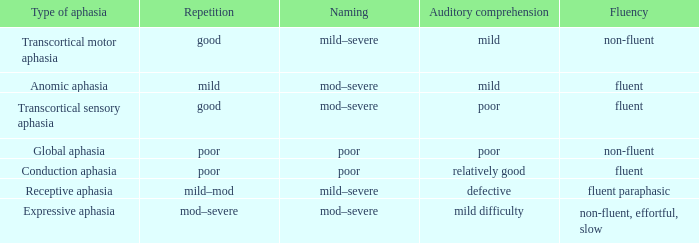Name the fluency for transcortical sensory aphasia Fluent. 